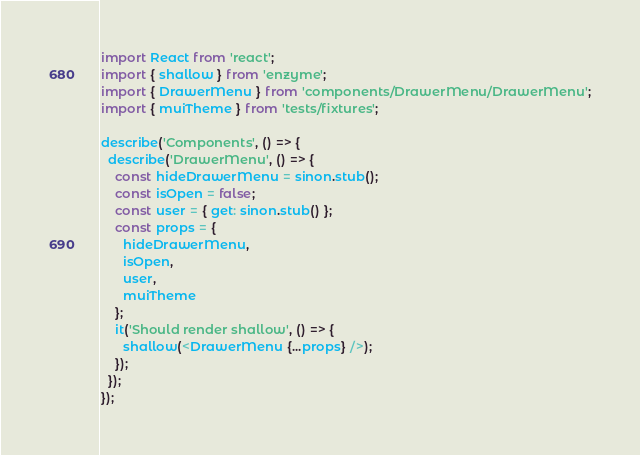<code> <loc_0><loc_0><loc_500><loc_500><_JavaScript_>import React from 'react';
import { shallow } from 'enzyme';
import { DrawerMenu } from 'components/DrawerMenu/DrawerMenu';
import { muiTheme } from 'tests/fixtures';

describe('Components', () => {
  describe('DrawerMenu', () => {
    const hideDrawerMenu = sinon.stub();
    const isOpen = false;
    const user = { get: sinon.stub() };
    const props = {
      hideDrawerMenu,
      isOpen,
      user,
      muiTheme
    };
    it('Should render shallow', () => {
      shallow(<DrawerMenu {...props} />);
    });
  });
});
</code> 